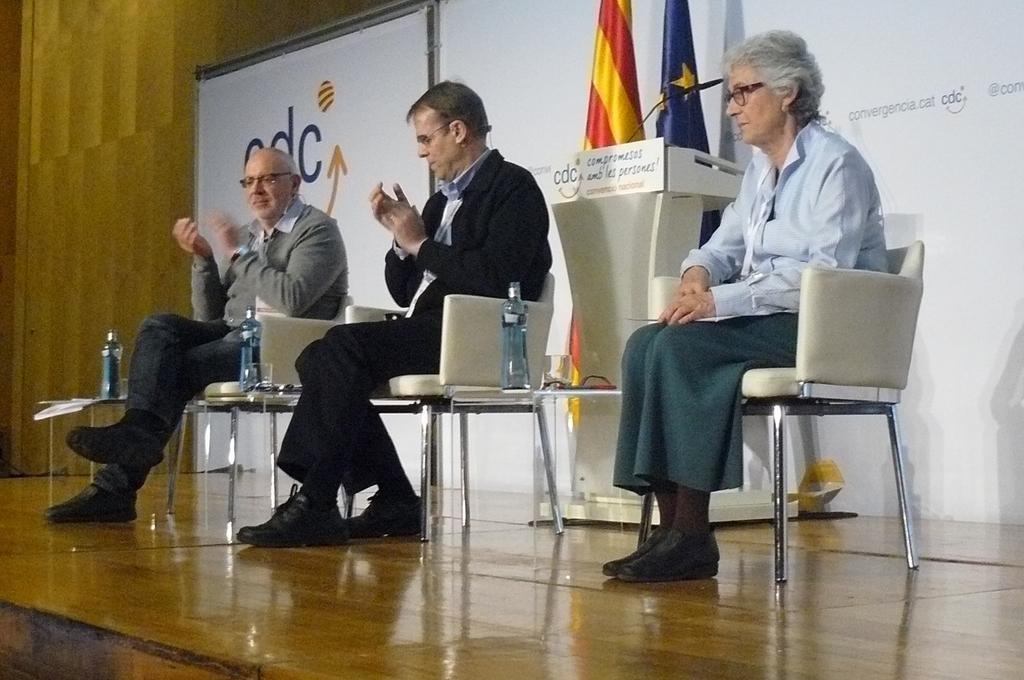Could you give a brief overview of what you see in this image? This picture shows two men and one woman seated on the chairs and clapping their hands and we see water bottles and Podium with a microphone and we also see two flags. 